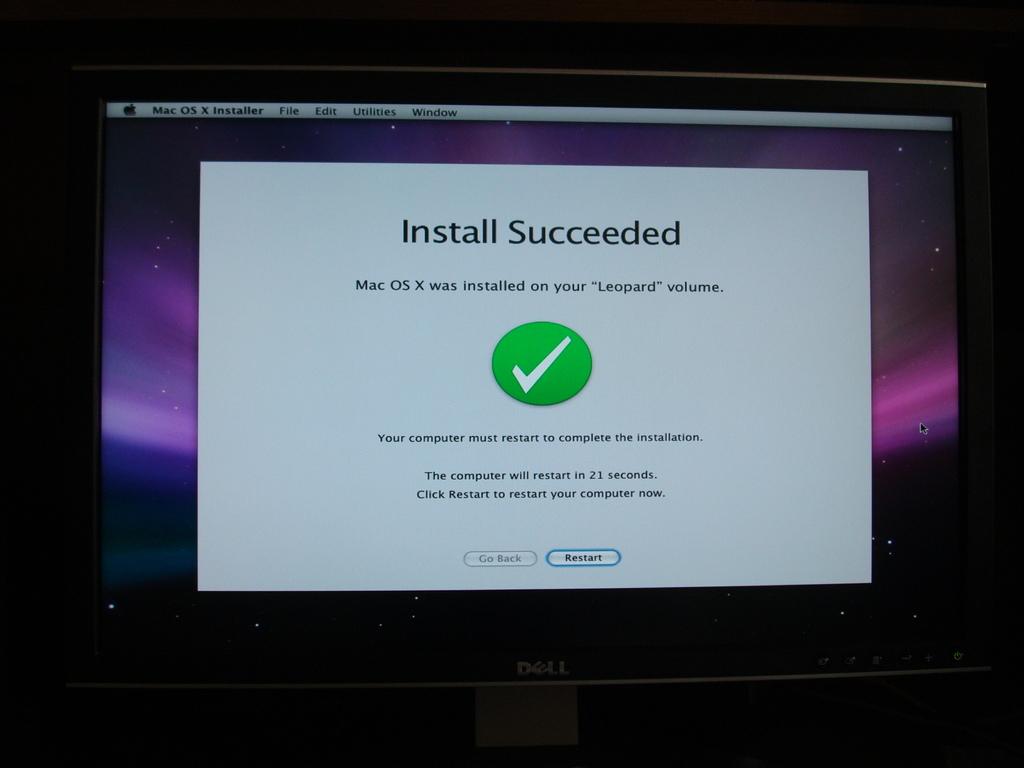What operating system has been installed?
Your answer should be compact. Mac os x. When will the computer restart?
Your response must be concise. 21 seconds. 